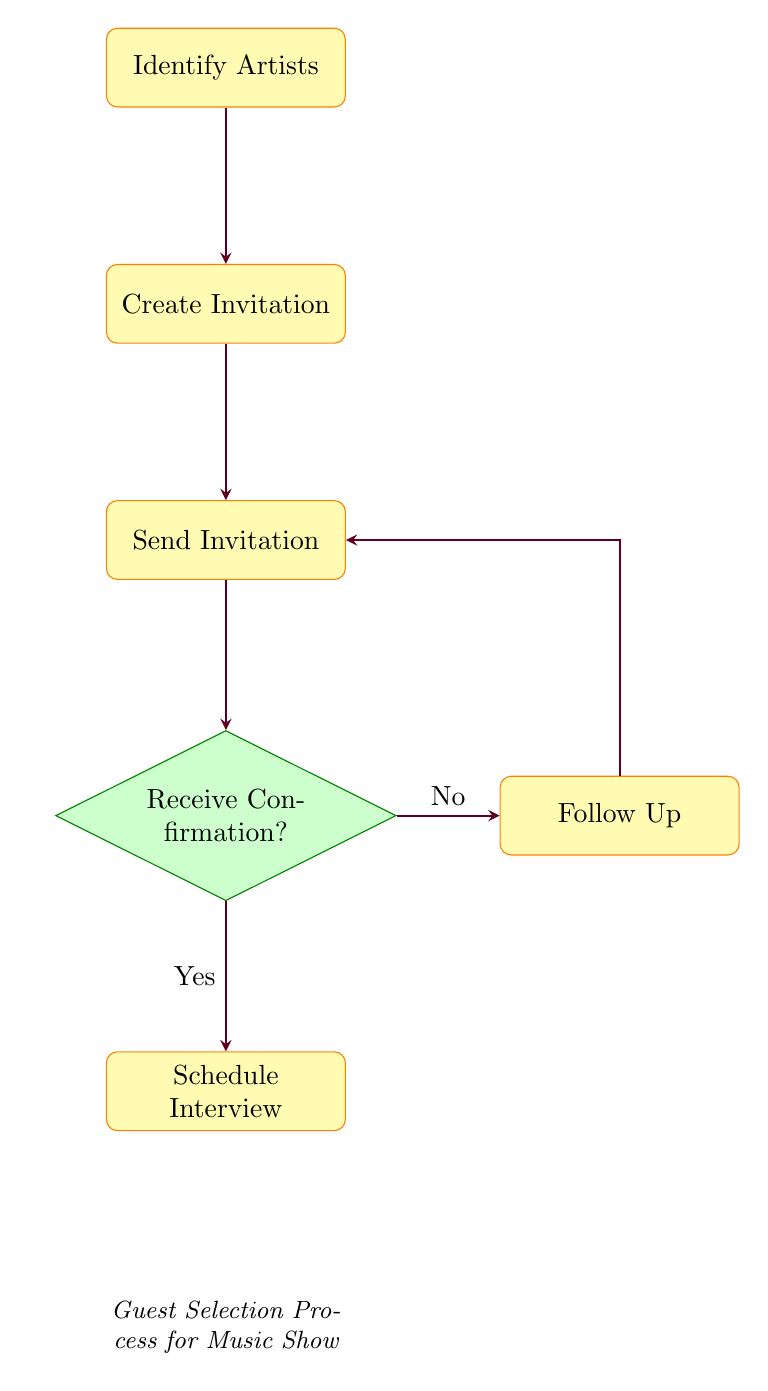What is the first step in the guest selection process? The first step in the flow chart is "Identify Artists," which indicates the initial action to be taken.
Answer: Identify Artists How many processes are there in the flow chart? There are five processes depicted in the diagram: Identify Artists, Create Invitation, Send Invitation, Follow Up, and Schedule Interview.
Answer: Five What happens if the confirmation is not received? If the confirmation is not received, the flow arrow leads to the "Follow Up" node, indicating an action to reach out again.
Answer: Follow Up Which node indicates a decision point? The "Receive Confirmation?" node is a decision diamond, representing a point where a decision must be made based on whether confirmation has been received or not.
Answer: Receive Confirmation? What is the final step if confirmation is received? Upon receiving confirmation, the next step indicated in the flow chart is "Schedule Interview," which is where the interview is arranged.
Answer: Schedule Interview Which two nodes are connected by a decision? The "Send Invitation" node and the "Receive Confirmation?" node are directly connected, creating a decision based on the confirmation outcome.
Answer: Send Invitation and Receive Confirmation What should be done after "Send Invitation" if there is no response? If there is no response to the invitation, the process requires taking the action from the "Receive Confirmation?" node to the "Follow Up" node.
Answer: Follow Up What is the relationship between "Receive Confirmation?" and "Schedule Interview"? The relationship is that if the answer to "Receive Confirmation?" is yes, it leads directly to the "Schedule Interview" process, indicating the next step.
Answer: Yes How does the flow return to "Send Invitation" after "Follow Up"? The flow connects from "Follow Up" back to "Send Invitation" via the arrow that loops from the follow-up action back to resend the original invitation.
Answer: Arrow from Follow Up to Send Invitation 